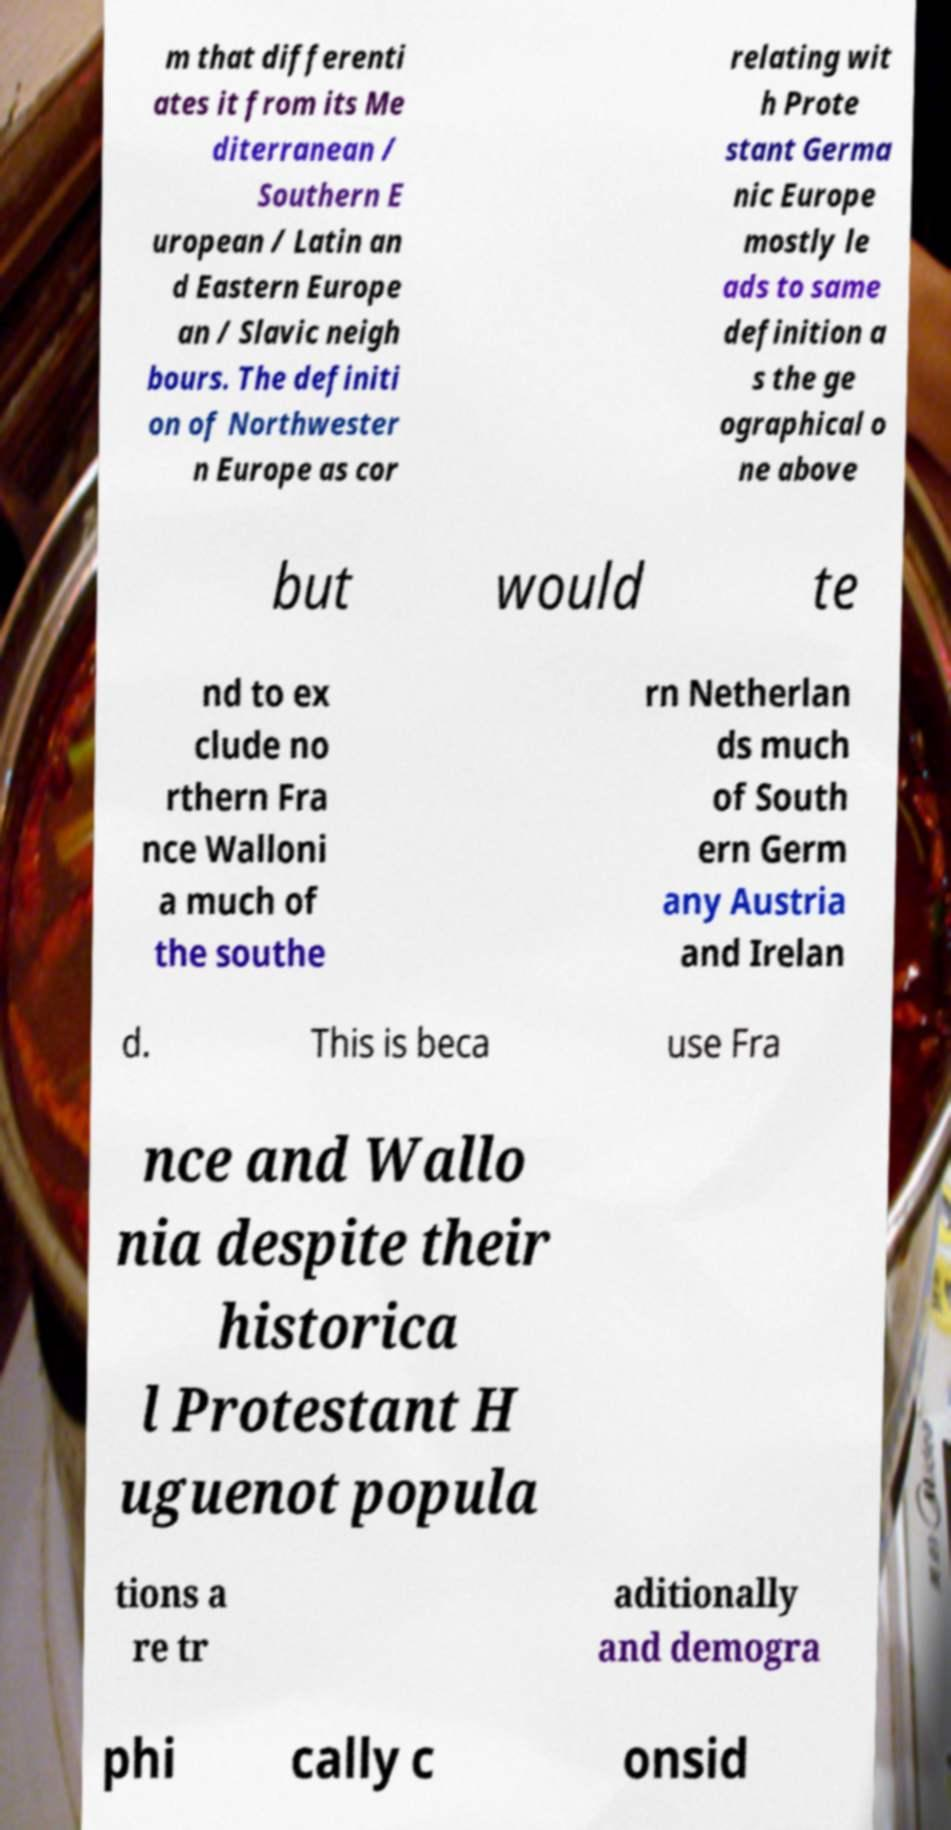There's text embedded in this image that I need extracted. Can you transcribe it verbatim? m that differenti ates it from its Me diterranean / Southern E uropean / Latin an d Eastern Europe an / Slavic neigh bours. The definiti on of Northwester n Europe as cor relating wit h Prote stant Germa nic Europe mostly le ads to same definition a s the ge ographical o ne above but would te nd to ex clude no rthern Fra nce Walloni a much of the southe rn Netherlan ds much of South ern Germ any Austria and Irelan d. This is beca use Fra nce and Wallo nia despite their historica l Protestant H uguenot popula tions a re tr aditionally and demogra phi cally c onsid 